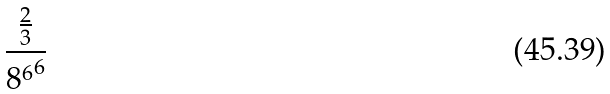<formula> <loc_0><loc_0><loc_500><loc_500>\frac { \frac { 2 } { 3 } } { { 8 ^ { 6 } } ^ { 6 } }</formula> 